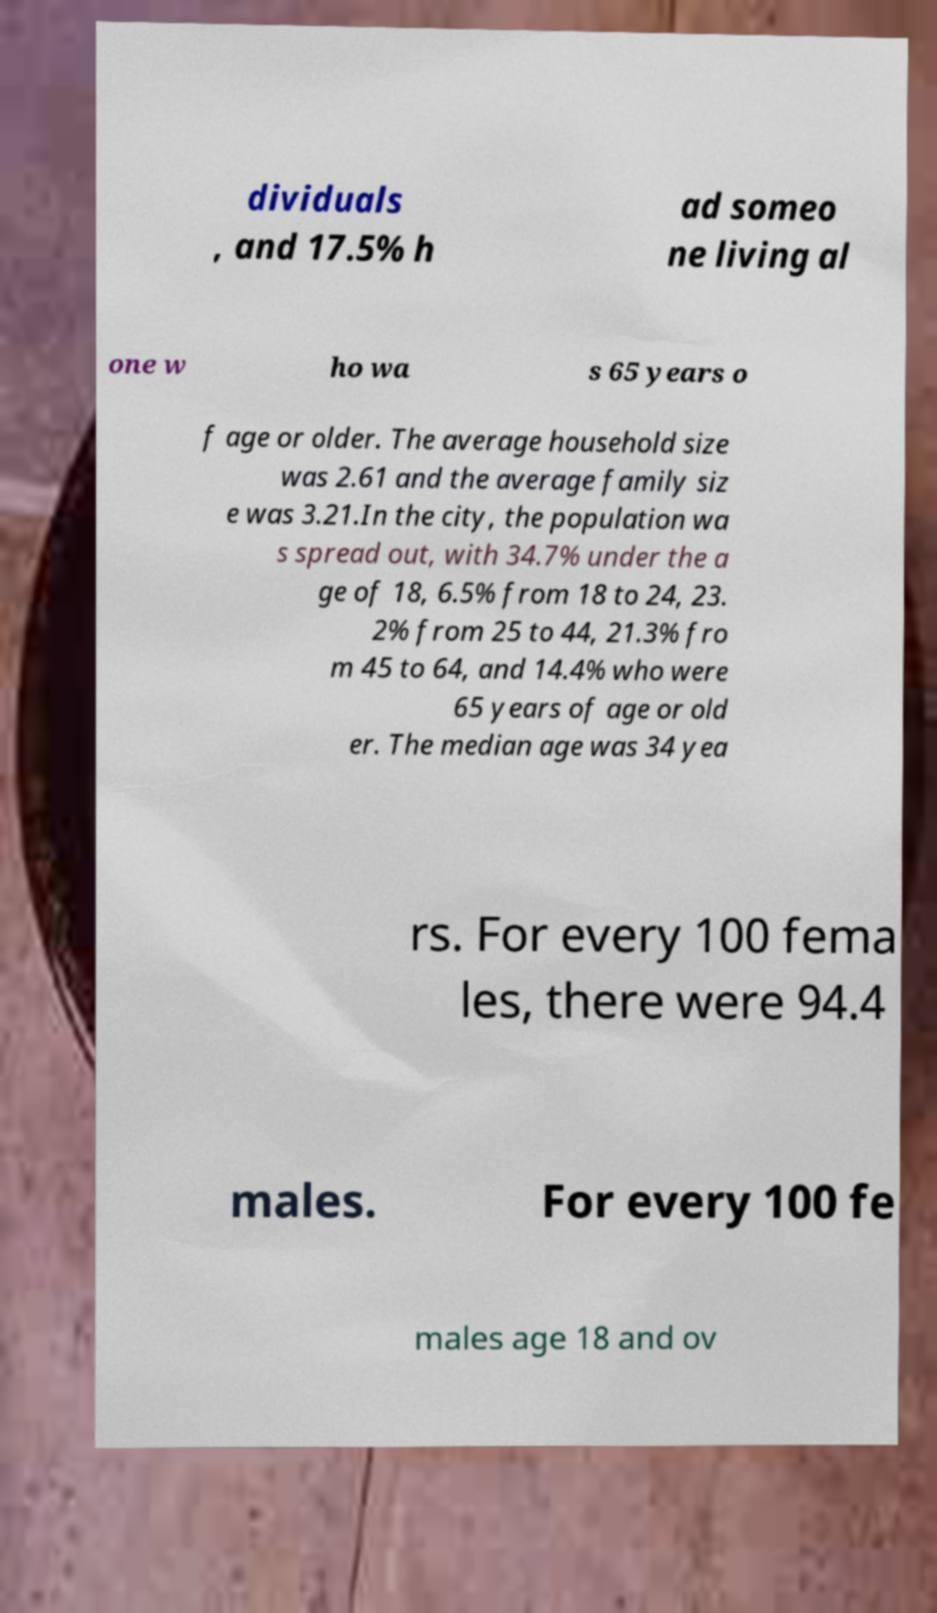Can you read and provide the text displayed in the image?This photo seems to have some interesting text. Can you extract and type it out for me? dividuals , and 17.5% h ad someo ne living al one w ho wa s 65 years o f age or older. The average household size was 2.61 and the average family siz e was 3.21.In the city, the population wa s spread out, with 34.7% under the a ge of 18, 6.5% from 18 to 24, 23. 2% from 25 to 44, 21.3% fro m 45 to 64, and 14.4% who were 65 years of age or old er. The median age was 34 yea rs. For every 100 fema les, there were 94.4 males. For every 100 fe males age 18 and ov 